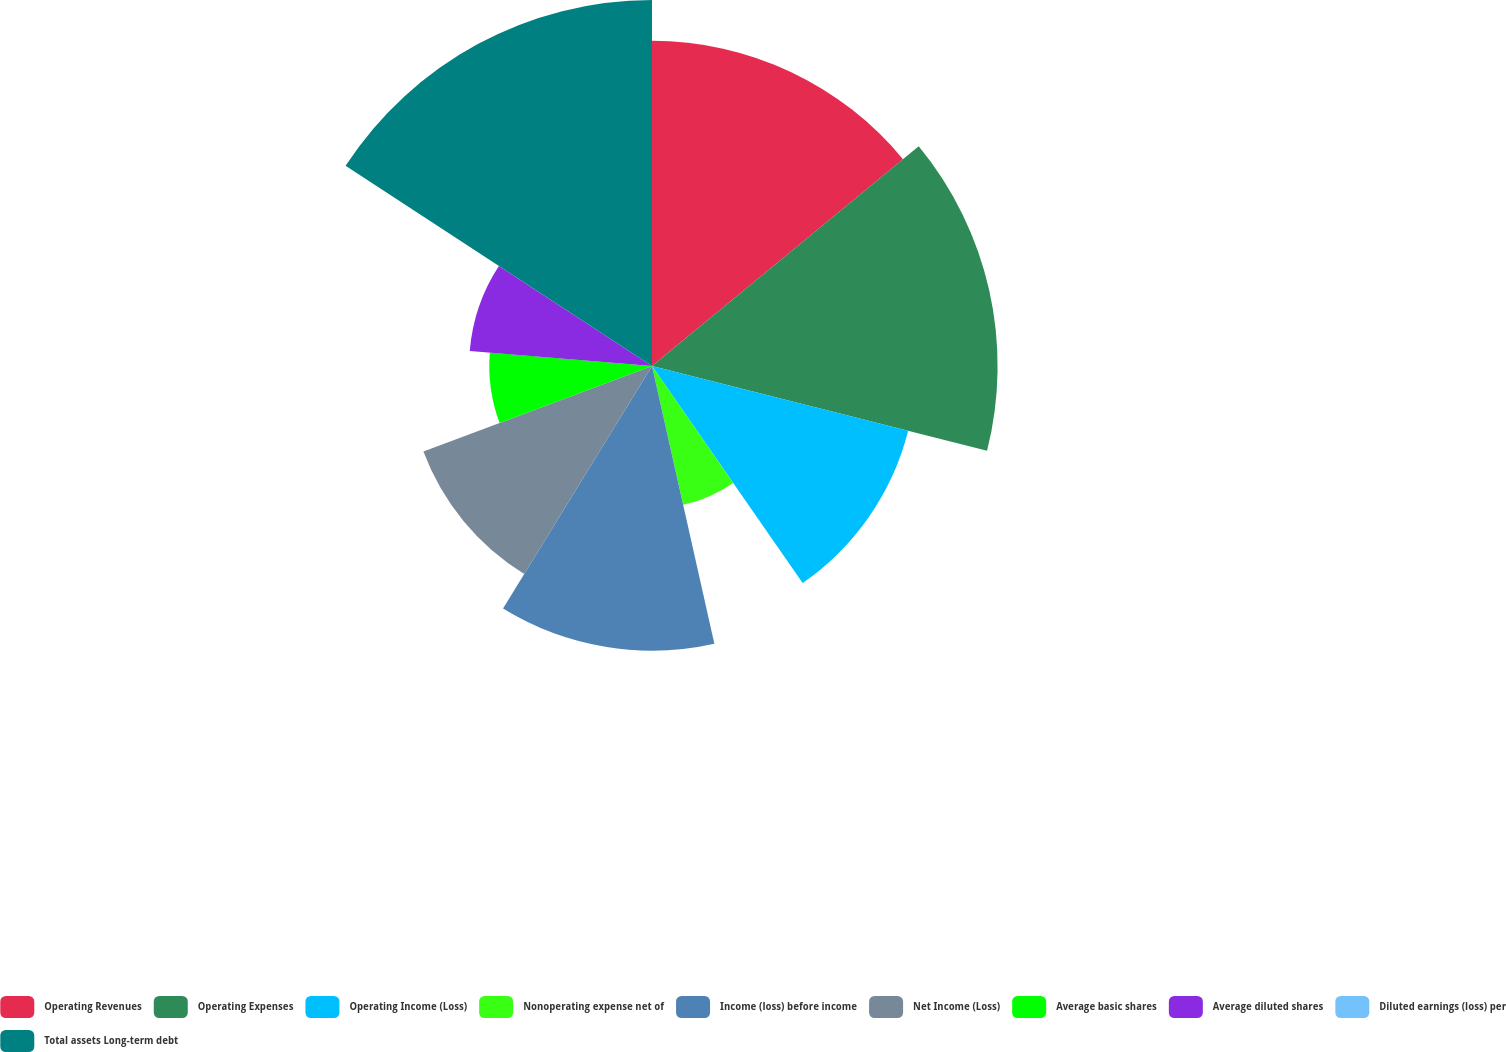Convert chart to OTSL. <chart><loc_0><loc_0><loc_500><loc_500><pie_chart><fcel>Operating Revenues<fcel>Operating Expenses<fcel>Operating Income (Loss)<fcel>Nonoperating expense net of<fcel>Income (loss) before income<fcel>Net Income (Loss)<fcel>Average basic shares<fcel>Average diluted shares<fcel>Diluted earnings (loss) per<fcel>Total assets Long-term debt<nl><fcel>14.03%<fcel>14.91%<fcel>11.4%<fcel>6.14%<fcel>12.28%<fcel>10.53%<fcel>7.02%<fcel>7.89%<fcel>0.0%<fcel>15.79%<nl></chart> 